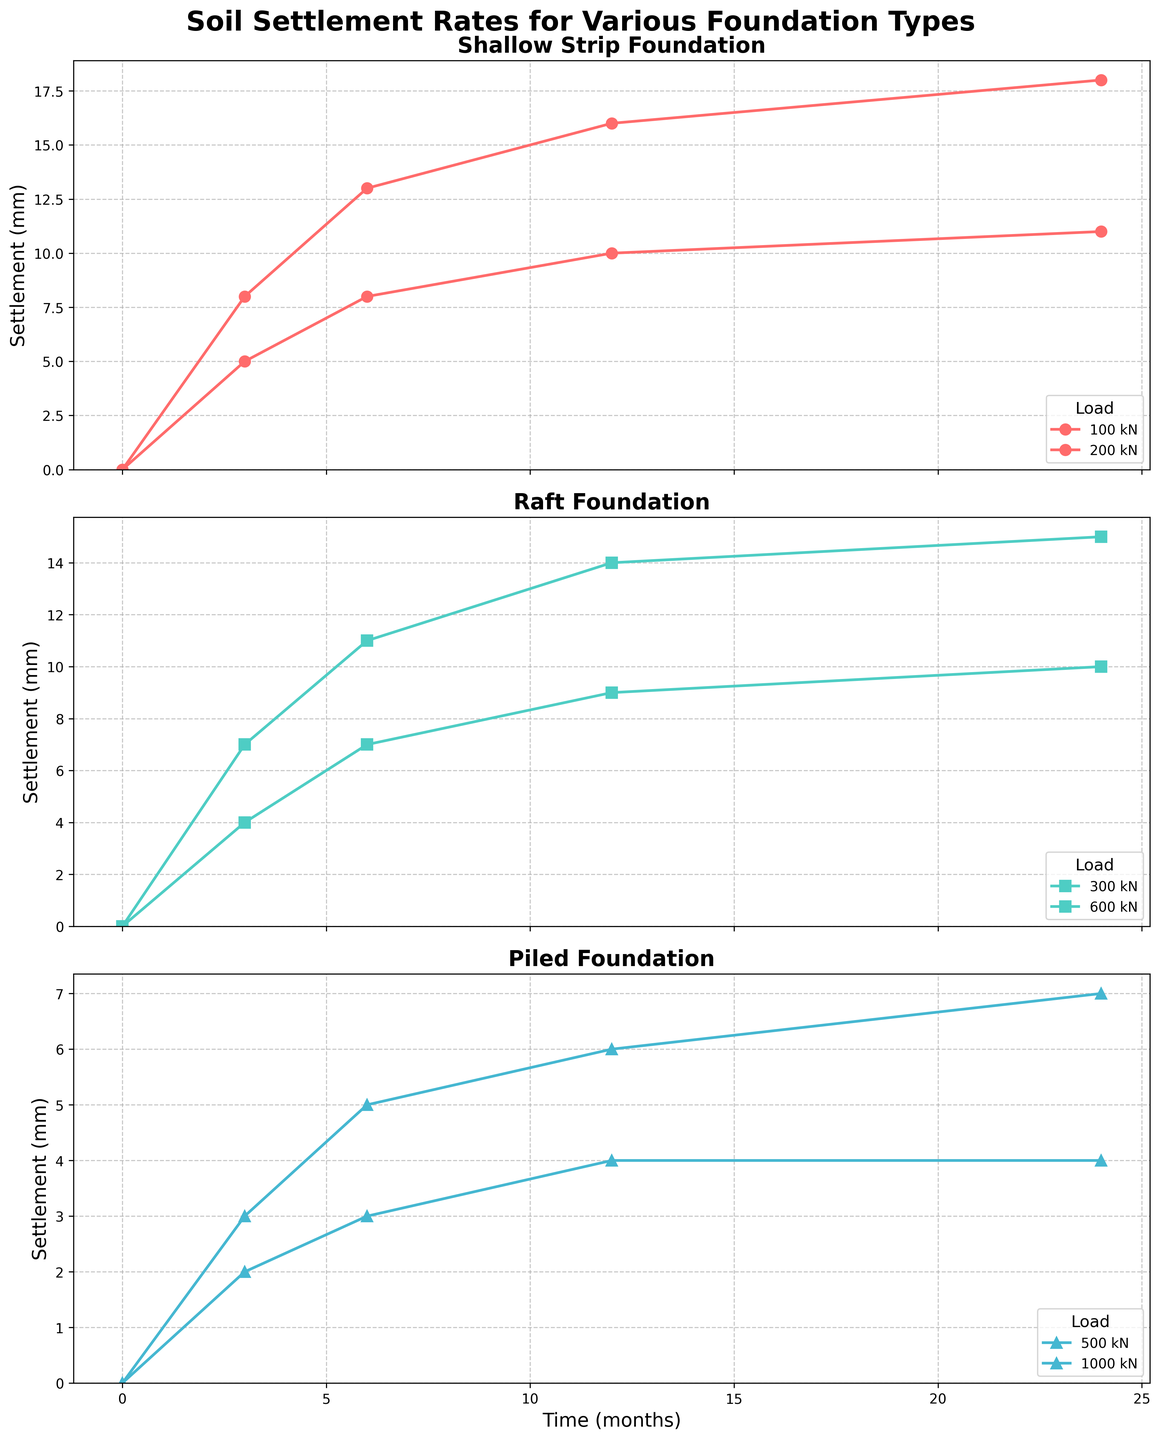What type of foundation shows a relatively constant settlement after 12 months regardless of load? In the subplot for the "Piled" foundation, we observe that the settlement for both loads (500 kN and 1000 kN) stabilizes between 4-7 mm after the first 12 months and remains constant through 24 months. This indicates a relatively constant settlement after 12 months for piled foundations.
Answer: Piled Which foundation type shows the greatest difference in settlement at 6 months between the lowest and highest loads? To answer this, we need to check the differences in settlement at 6 months for each foundation type. For "Shallow Strip," the difference is 5 mm (13 mm - 8 mm). For "Raft," the difference is 4 mm (11 mm - 7 mm). For "Piled," the difference is 2 mm (5 mm - 3 mm). The shallow strip foundation shows the greatest difference.
Answer: Shallow Strip What is the total settlement for the Raft foundation under a 600 kN load over the 24 months? Adding the settlement values at each time point (3, 6, 12, 24 months) for Raft foundation under 600 kN load: 0 + 7 + 11 + 14 + 15 mm. So, the total settlement is 15 mm.
Answer: 15 mm How does the settlement trend for the shallow strip foundation under a 100 kN load compare to the same foundation under a 200 kN load over time? The settlement trend for the 100 kN load shows a gradual increase and starts to taper off at 11 mm by 24 months. The 200 kN load also shows a gradual upward trend but with higher values, settling at 18 mm by 24 months. Thus, the 200 kN load consistently causes more settlement than the 100 kN load.
Answer: 200 kN has more settlement Visualizing all foundation types, which foundation shows the least settlement rate visually over the observed period? Overall, looking at all three subplots, the Piled foundation shows the least settlement rate compared to Shallow Strip and Raft foundations. Specifically, it plateaus at much lower values (approximately 4-7 mm) compared to others.
Answer: Piled Rank the foundations from most to least concerning increase in settlement over time with regards to piling at 500 kN load, raft at 300 kN load, and shallow strip at 200 kN load by 24 months. Considering the 24 months settlement data: For Piled 500 kN = 4 mm, Raft 300 kN = 10 mm, and Shallow Strip 200 kN = 18 mm. Ranking them: Shallow Strip (200 kN) > Raft (300 kN) > Piled (500 kN).
Answer: Shallow Strip > Raft > Piled At what month does the settlement curve for Raft foundation under a 300 kN load first show a noticeable change in slope? Analyzing the graph for Raft under a 300 kN load, the data shows a noticeable change in the slope around 3 months, changing from a rapid increase to a more gradual increase.
Answer: 3 months By how much does the settlement under Raft foundation with a load of 600 kN change between 3 and 24 months? From the Raft foundation's data with a 600 kN load, the settlement at 3 months is 7 mm, and at 24 months is 15 mm. Thus, the change is 15 mm - 7 mm = 8 mm.
Answer: 8 mm 